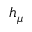<formula> <loc_0><loc_0><loc_500><loc_500>h _ { \mu }</formula> 